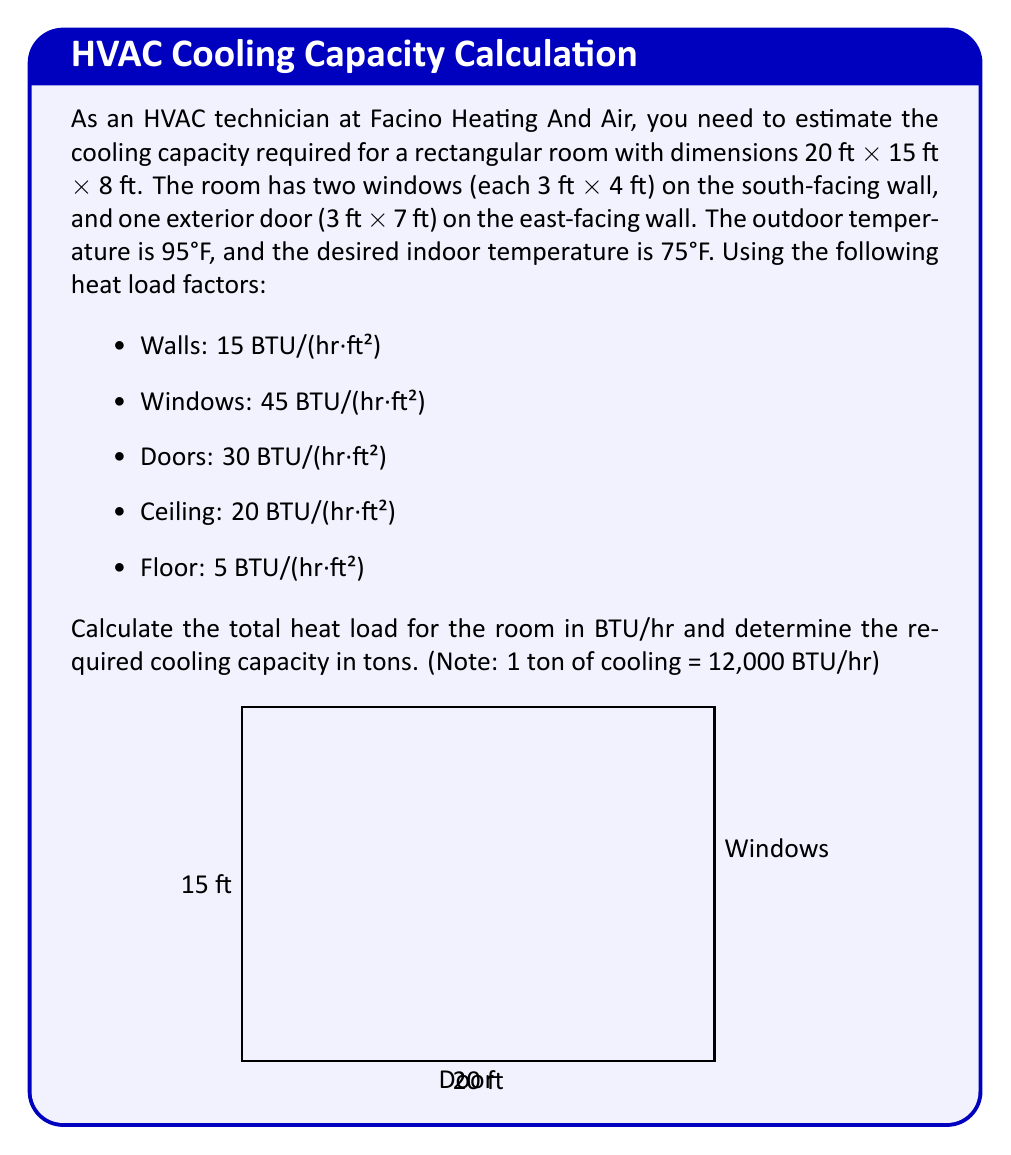Teach me how to tackle this problem. Let's break this down step-by-step:

1) Calculate the surface areas:
   - Floor and ceiling: $20 \text{ ft} \times 15 \text{ ft} = 300 \text{ ft}^2$ each
   - North and south walls: $20 \text{ ft} \times 8 \text{ ft} = 160 \text{ ft}^2$ each
   - East and west walls: $15 \text{ ft} \times 8 \text{ ft} = 120 \text{ ft}^2$ each
   - Windows: $2 \times (3 \text{ ft} \times 4 \text{ ft}) = 24 \text{ ft}^2$ total
   - Door: $3 \text{ ft} \times 7 \text{ ft} = 21 \text{ ft}^2$

2) Calculate the heat load for each surface:
   - Floor: $300 \text{ ft}^2 \times 5 \text{ BTU}/(hr\cdot ft^2) = 1,500 \text{ BTU}/hr$
   - Ceiling: $300 \text{ ft}^2 \times 20 \text{ BTU}/(hr\cdot ft^2) = 6,000 \text{ BTU}/hr$
   - North wall: $160 \text{ ft}^2 \times 15 \text{ BTU}/(hr\cdot ft^2) = 2,400 \text{ BTU}/hr$
   - South wall: $(160 - 24) \text{ ft}^2 \times 15 \text{ BTU}/(hr\cdot ft^2) = 2,040 \text{ BTU}/hr$
   - East wall: $(120 - 21) \text{ ft}^2 \times 15 \text{ BTU}/(hr\cdot ft^2) = 1,485 \text{ BTU}/hr$
   - West wall: $120 \text{ ft}^2 \times 15 \text{ BTU}/(hr\cdot ft^2) = 1,800 \text{ BTU}/hr$
   - Windows: $24 \text{ ft}^2 \times 45 \text{ BTU}/(hr\cdot ft^2) = 1,080 \text{ BTU}/hr$
   - Door: $21 \text{ ft}^2 \times 30 \text{ BTU}/(hr\cdot ft^2) = 630 \text{ BTU}/hr$

3) Sum up the total heat load:
   $$\text{Total Heat Load} = 1,500 + 6,000 + 2,400 + 2,040 + 1,485 + 1,800 + 1,080 + 630 = 16,935 \text{ BTU}/hr$$

4) Convert BTU/hr to tons:
   $$\text{Cooling Capacity} = \frac{16,935 \text{ BTU}/hr}{12,000 \text{ BTU}/(\text{hr}\cdot\text{ton})} = 1.41 \text{ tons}$$

Therefore, the required cooling capacity for the room is approximately 1.41 tons.
Answer: 1.41 tons 